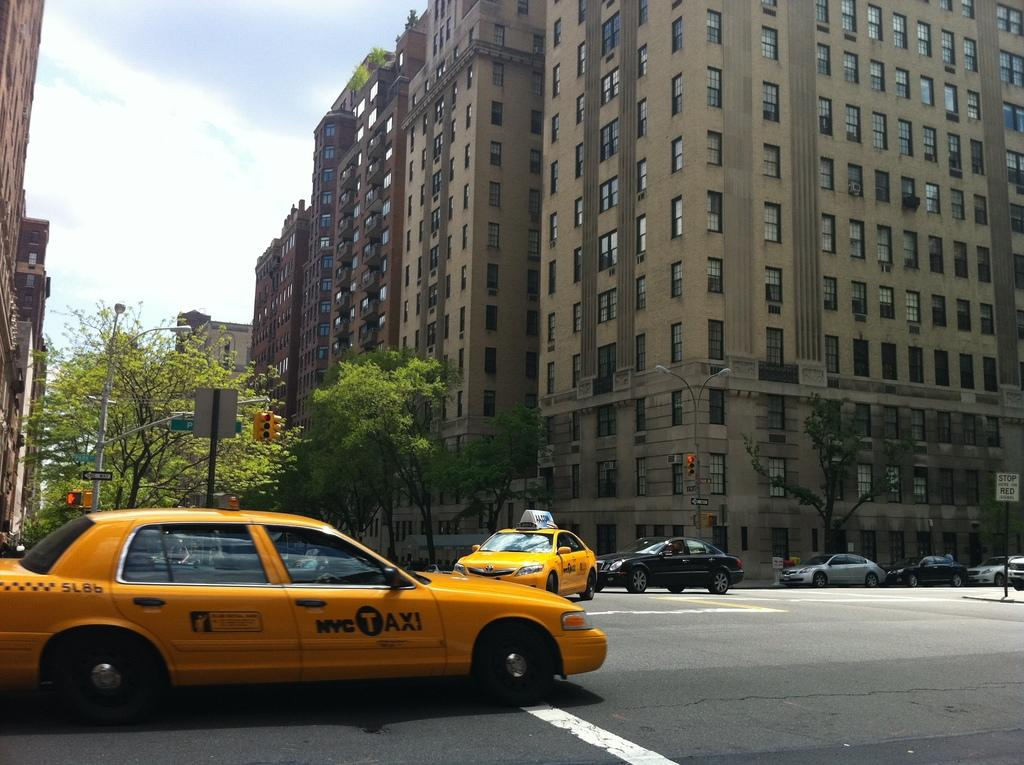<image>
Give a short and clear explanation of the subsequent image. A yellow cab zips by with NYC Taxi on its door. 